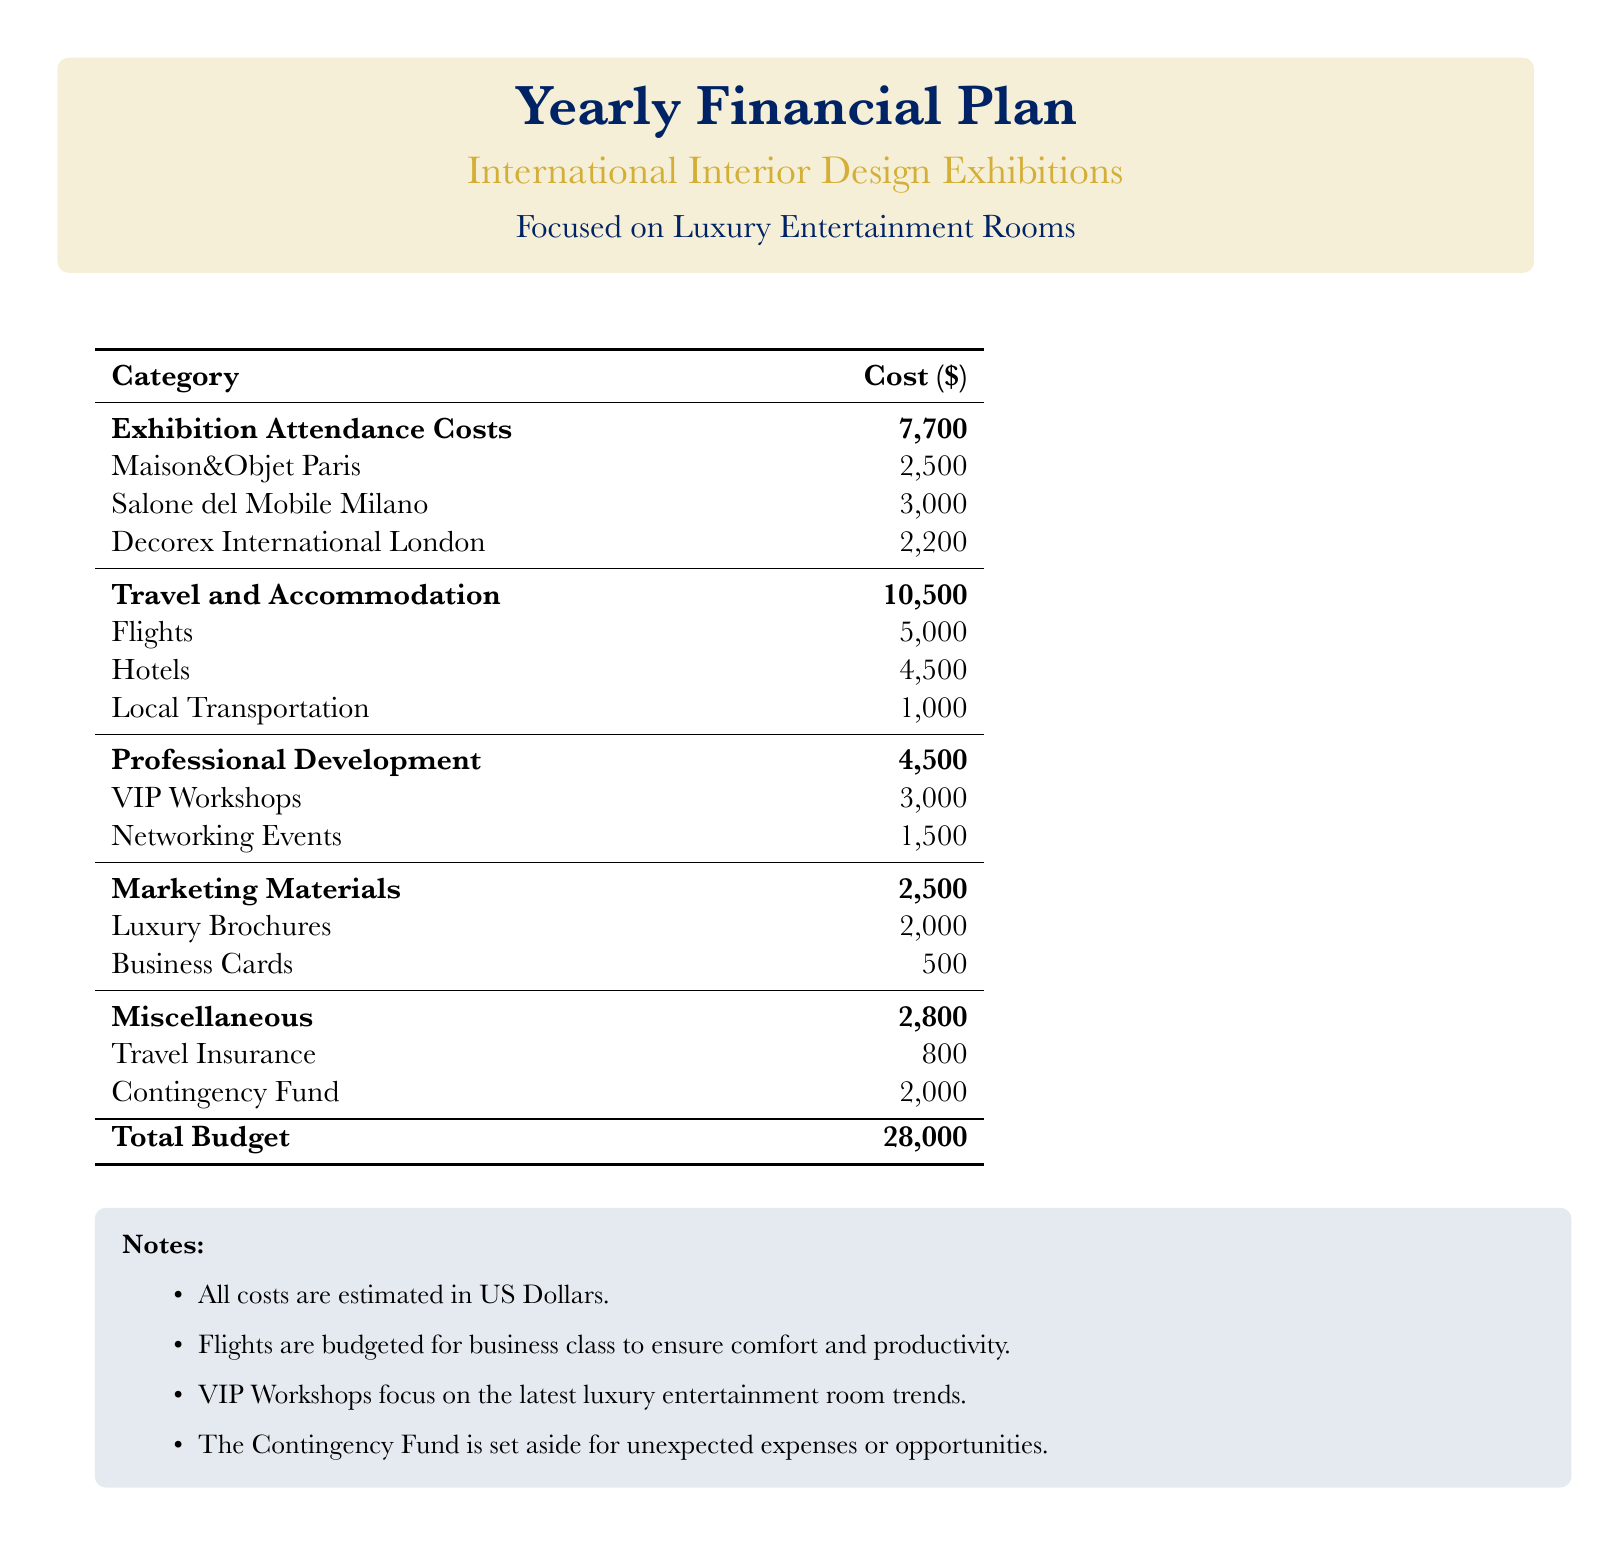What is the total budget? The total budget is the sum of all categories listed in the document.
Answer: $28,000 How much is allocated for exhibition attendance costs? The budget for exhibition attendance is specifically listed in the document.
Answer: $7,700 What is the cost of attending Salone del Mobile Milano? The specific cost for Salone del Mobile Milano is provided in the table.
Answer: $3,000 What is the budget for travel and accommodation? The cost for travel and accommodation is detailed in the document.
Answer: $10,500 How much is set aside for VIP workshops? The amount allocated for VIP workshops is specified in the professional development category.
Answer: $3,000 What is the amount for the contingency fund? The contingency fund amount is explicitly stated in the miscellaneous category.
Answer: $2,000 How much is budgeted for luxury brochures? The budgeted amount for luxury brochures is directly listed in the marketing materials section.
Answer: $2,000 What is the cost for networking events? The document clearly mentions the specific cost allocated for networking events.
Answer: $1,500 How much is allocated for travel insurance? The specific amount set aside for travel insurance is detailed in the miscellaneous section.
Answer: $800 